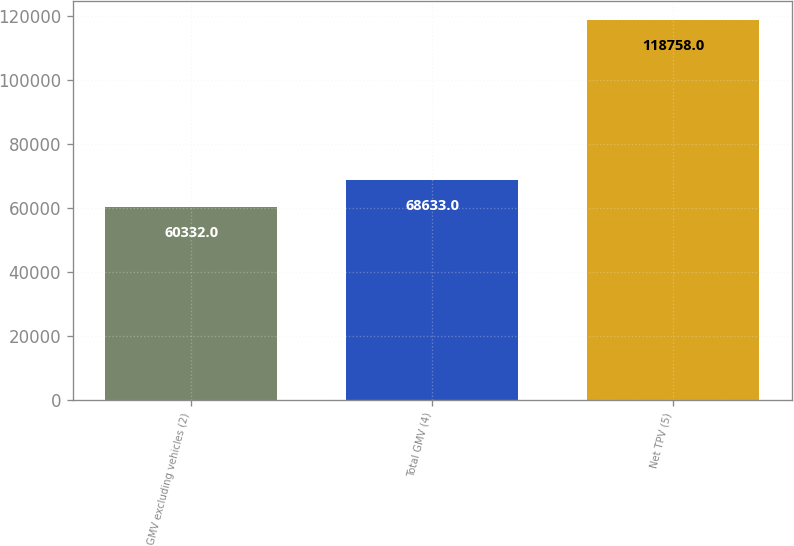Convert chart. <chart><loc_0><loc_0><loc_500><loc_500><bar_chart><fcel>GMV excluding vehicles (2)<fcel>Total GMV (4)<fcel>Net TPV (5)<nl><fcel>60332<fcel>68633<fcel>118758<nl></chart> 